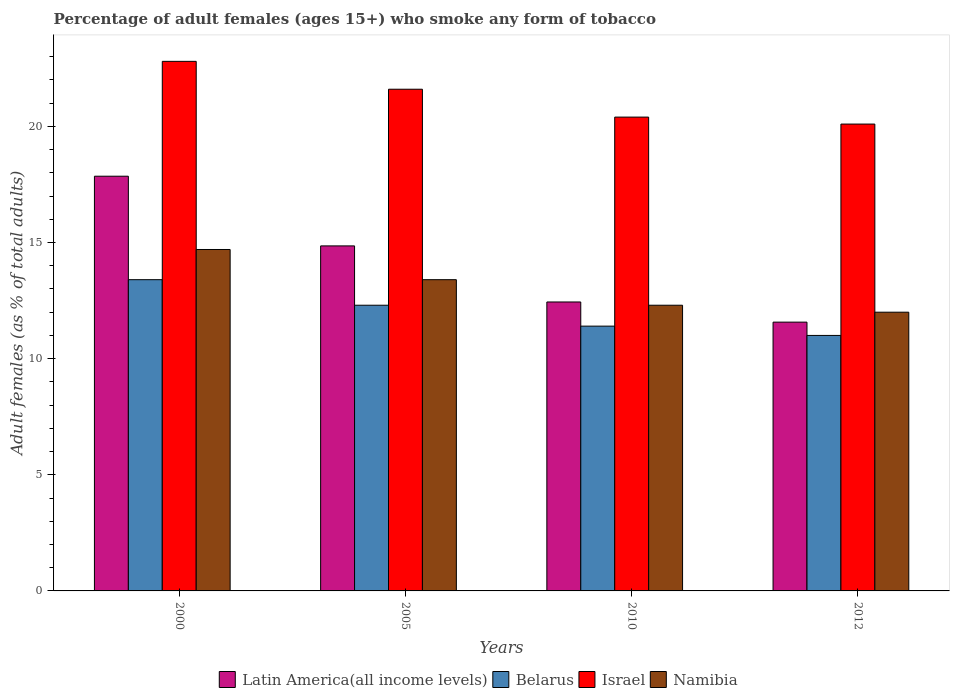How many groups of bars are there?
Keep it short and to the point. 4. Are the number of bars per tick equal to the number of legend labels?
Make the answer very short. Yes. Are the number of bars on each tick of the X-axis equal?
Your answer should be compact. Yes. How many bars are there on the 2nd tick from the left?
Your answer should be very brief. 4. What is the label of the 4th group of bars from the left?
Keep it short and to the point. 2012. In how many cases, is the number of bars for a given year not equal to the number of legend labels?
Your response must be concise. 0. What is the percentage of adult females who smoke in Belarus in 2012?
Your answer should be very brief. 11. Across all years, what is the maximum percentage of adult females who smoke in Latin America(all income levels)?
Keep it short and to the point. 17.85. Across all years, what is the minimum percentage of adult females who smoke in Latin America(all income levels)?
Ensure brevity in your answer.  11.57. In which year was the percentage of adult females who smoke in Namibia minimum?
Offer a terse response. 2012. What is the total percentage of adult females who smoke in Namibia in the graph?
Offer a very short reply. 52.4. What is the difference between the percentage of adult females who smoke in Namibia in 2000 and that in 2010?
Your response must be concise. 2.4. What is the difference between the percentage of adult females who smoke in Latin America(all income levels) in 2005 and the percentage of adult females who smoke in Namibia in 2012?
Your response must be concise. 2.85. What is the average percentage of adult females who smoke in Israel per year?
Give a very brief answer. 21.23. In the year 2010, what is the difference between the percentage of adult females who smoke in Israel and percentage of adult females who smoke in Namibia?
Make the answer very short. 8.1. In how many years, is the percentage of adult females who smoke in Belarus greater than 7 %?
Give a very brief answer. 4. What is the ratio of the percentage of adult females who smoke in Belarus in 2005 to that in 2010?
Provide a succinct answer. 1.08. Is the difference between the percentage of adult females who smoke in Israel in 2000 and 2005 greater than the difference between the percentage of adult females who smoke in Namibia in 2000 and 2005?
Ensure brevity in your answer.  No. What is the difference between the highest and the second highest percentage of adult females who smoke in Israel?
Your response must be concise. 1.2. What is the difference between the highest and the lowest percentage of adult females who smoke in Israel?
Keep it short and to the point. 2.7. In how many years, is the percentage of adult females who smoke in Namibia greater than the average percentage of adult females who smoke in Namibia taken over all years?
Provide a short and direct response. 2. Is the sum of the percentage of adult females who smoke in Belarus in 2005 and 2012 greater than the maximum percentage of adult females who smoke in Israel across all years?
Offer a terse response. Yes. Is it the case that in every year, the sum of the percentage of adult females who smoke in Latin America(all income levels) and percentage of adult females who smoke in Namibia is greater than the sum of percentage of adult females who smoke in Belarus and percentage of adult females who smoke in Israel?
Provide a short and direct response. No. What does the 3rd bar from the right in 2012 represents?
Offer a very short reply. Belarus. How many bars are there?
Offer a terse response. 16. Does the graph contain any zero values?
Your answer should be very brief. No. Where does the legend appear in the graph?
Ensure brevity in your answer.  Bottom center. How many legend labels are there?
Provide a succinct answer. 4. What is the title of the graph?
Offer a terse response. Percentage of adult females (ages 15+) who smoke any form of tobacco. Does "Albania" appear as one of the legend labels in the graph?
Offer a terse response. No. What is the label or title of the Y-axis?
Make the answer very short. Adult females (as % of total adults). What is the Adult females (as % of total adults) of Latin America(all income levels) in 2000?
Give a very brief answer. 17.85. What is the Adult females (as % of total adults) of Belarus in 2000?
Provide a short and direct response. 13.4. What is the Adult females (as % of total adults) in Israel in 2000?
Your response must be concise. 22.8. What is the Adult females (as % of total adults) in Namibia in 2000?
Make the answer very short. 14.7. What is the Adult females (as % of total adults) in Latin America(all income levels) in 2005?
Your answer should be very brief. 14.85. What is the Adult females (as % of total adults) in Belarus in 2005?
Give a very brief answer. 12.3. What is the Adult females (as % of total adults) in Israel in 2005?
Your answer should be very brief. 21.6. What is the Adult females (as % of total adults) of Latin America(all income levels) in 2010?
Make the answer very short. 12.44. What is the Adult females (as % of total adults) of Israel in 2010?
Your answer should be very brief. 20.4. What is the Adult females (as % of total adults) of Latin America(all income levels) in 2012?
Offer a very short reply. 11.57. What is the Adult females (as % of total adults) of Israel in 2012?
Your response must be concise. 20.1. Across all years, what is the maximum Adult females (as % of total adults) in Latin America(all income levels)?
Your answer should be compact. 17.85. Across all years, what is the maximum Adult females (as % of total adults) of Belarus?
Make the answer very short. 13.4. Across all years, what is the maximum Adult females (as % of total adults) of Israel?
Give a very brief answer. 22.8. Across all years, what is the maximum Adult females (as % of total adults) in Namibia?
Offer a terse response. 14.7. Across all years, what is the minimum Adult females (as % of total adults) of Latin America(all income levels)?
Keep it short and to the point. 11.57. Across all years, what is the minimum Adult females (as % of total adults) in Israel?
Keep it short and to the point. 20.1. Across all years, what is the minimum Adult females (as % of total adults) of Namibia?
Make the answer very short. 12. What is the total Adult females (as % of total adults) in Latin America(all income levels) in the graph?
Ensure brevity in your answer.  56.72. What is the total Adult females (as % of total adults) of Belarus in the graph?
Your answer should be very brief. 48.1. What is the total Adult females (as % of total adults) of Israel in the graph?
Your answer should be very brief. 84.9. What is the total Adult females (as % of total adults) in Namibia in the graph?
Provide a succinct answer. 52.4. What is the difference between the Adult females (as % of total adults) of Latin America(all income levels) in 2000 and that in 2005?
Provide a succinct answer. 3. What is the difference between the Adult females (as % of total adults) of Belarus in 2000 and that in 2005?
Ensure brevity in your answer.  1.1. What is the difference between the Adult females (as % of total adults) of Namibia in 2000 and that in 2005?
Provide a succinct answer. 1.3. What is the difference between the Adult females (as % of total adults) in Latin America(all income levels) in 2000 and that in 2010?
Give a very brief answer. 5.41. What is the difference between the Adult females (as % of total adults) of Belarus in 2000 and that in 2010?
Offer a terse response. 2. What is the difference between the Adult females (as % of total adults) of Israel in 2000 and that in 2010?
Give a very brief answer. 2.4. What is the difference between the Adult females (as % of total adults) of Namibia in 2000 and that in 2010?
Make the answer very short. 2.4. What is the difference between the Adult females (as % of total adults) in Latin America(all income levels) in 2000 and that in 2012?
Your answer should be very brief. 6.28. What is the difference between the Adult females (as % of total adults) of Israel in 2000 and that in 2012?
Offer a very short reply. 2.7. What is the difference between the Adult females (as % of total adults) of Latin America(all income levels) in 2005 and that in 2010?
Your response must be concise. 2.41. What is the difference between the Adult females (as % of total adults) of Belarus in 2005 and that in 2010?
Your answer should be very brief. 0.9. What is the difference between the Adult females (as % of total adults) of Namibia in 2005 and that in 2010?
Make the answer very short. 1.1. What is the difference between the Adult females (as % of total adults) of Latin America(all income levels) in 2005 and that in 2012?
Keep it short and to the point. 3.28. What is the difference between the Adult females (as % of total adults) of Belarus in 2005 and that in 2012?
Give a very brief answer. 1.3. What is the difference between the Adult females (as % of total adults) in Namibia in 2005 and that in 2012?
Your response must be concise. 1.4. What is the difference between the Adult females (as % of total adults) of Latin America(all income levels) in 2010 and that in 2012?
Your answer should be very brief. 0.87. What is the difference between the Adult females (as % of total adults) of Belarus in 2010 and that in 2012?
Make the answer very short. 0.4. What is the difference between the Adult females (as % of total adults) in Latin America(all income levels) in 2000 and the Adult females (as % of total adults) in Belarus in 2005?
Your answer should be compact. 5.55. What is the difference between the Adult females (as % of total adults) of Latin America(all income levels) in 2000 and the Adult females (as % of total adults) of Israel in 2005?
Provide a short and direct response. -3.75. What is the difference between the Adult females (as % of total adults) of Latin America(all income levels) in 2000 and the Adult females (as % of total adults) of Namibia in 2005?
Ensure brevity in your answer.  4.45. What is the difference between the Adult females (as % of total adults) of Belarus in 2000 and the Adult females (as % of total adults) of Israel in 2005?
Provide a succinct answer. -8.2. What is the difference between the Adult females (as % of total adults) in Israel in 2000 and the Adult females (as % of total adults) in Namibia in 2005?
Provide a short and direct response. 9.4. What is the difference between the Adult females (as % of total adults) of Latin America(all income levels) in 2000 and the Adult females (as % of total adults) of Belarus in 2010?
Your answer should be compact. 6.45. What is the difference between the Adult females (as % of total adults) of Latin America(all income levels) in 2000 and the Adult females (as % of total adults) of Israel in 2010?
Your response must be concise. -2.55. What is the difference between the Adult females (as % of total adults) in Latin America(all income levels) in 2000 and the Adult females (as % of total adults) in Namibia in 2010?
Your answer should be compact. 5.55. What is the difference between the Adult females (as % of total adults) of Belarus in 2000 and the Adult females (as % of total adults) of Israel in 2010?
Your answer should be very brief. -7. What is the difference between the Adult females (as % of total adults) of Israel in 2000 and the Adult females (as % of total adults) of Namibia in 2010?
Offer a terse response. 10.5. What is the difference between the Adult females (as % of total adults) in Latin America(all income levels) in 2000 and the Adult females (as % of total adults) in Belarus in 2012?
Your response must be concise. 6.85. What is the difference between the Adult females (as % of total adults) of Latin America(all income levels) in 2000 and the Adult females (as % of total adults) of Israel in 2012?
Your answer should be very brief. -2.25. What is the difference between the Adult females (as % of total adults) in Latin America(all income levels) in 2000 and the Adult females (as % of total adults) in Namibia in 2012?
Give a very brief answer. 5.85. What is the difference between the Adult females (as % of total adults) in Belarus in 2000 and the Adult females (as % of total adults) in Israel in 2012?
Ensure brevity in your answer.  -6.7. What is the difference between the Adult females (as % of total adults) in Latin America(all income levels) in 2005 and the Adult females (as % of total adults) in Belarus in 2010?
Your answer should be compact. 3.45. What is the difference between the Adult females (as % of total adults) of Latin America(all income levels) in 2005 and the Adult females (as % of total adults) of Israel in 2010?
Provide a succinct answer. -5.55. What is the difference between the Adult females (as % of total adults) in Latin America(all income levels) in 2005 and the Adult females (as % of total adults) in Namibia in 2010?
Provide a short and direct response. 2.55. What is the difference between the Adult females (as % of total adults) in Israel in 2005 and the Adult females (as % of total adults) in Namibia in 2010?
Your response must be concise. 9.3. What is the difference between the Adult females (as % of total adults) of Latin America(all income levels) in 2005 and the Adult females (as % of total adults) of Belarus in 2012?
Keep it short and to the point. 3.85. What is the difference between the Adult females (as % of total adults) of Latin America(all income levels) in 2005 and the Adult females (as % of total adults) of Israel in 2012?
Keep it short and to the point. -5.25. What is the difference between the Adult females (as % of total adults) of Latin America(all income levels) in 2005 and the Adult females (as % of total adults) of Namibia in 2012?
Offer a terse response. 2.85. What is the difference between the Adult females (as % of total adults) in Belarus in 2005 and the Adult females (as % of total adults) in Israel in 2012?
Provide a succinct answer. -7.8. What is the difference between the Adult females (as % of total adults) in Belarus in 2005 and the Adult females (as % of total adults) in Namibia in 2012?
Make the answer very short. 0.3. What is the difference between the Adult females (as % of total adults) in Latin America(all income levels) in 2010 and the Adult females (as % of total adults) in Belarus in 2012?
Your answer should be compact. 1.44. What is the difference between the Adult females (as % of total adults) of Latin America(all income levels) in 2010 and the Adult females (as % of total adults) of Israel in 2012?
Ensure brevity in your answer.  -7.66. What is the difference between the Adult females (as % of total adults) in Latin America(all income levels) in 2010 and the Adult females (as % of total adults) in Namibia in 2012?
Offer a very short reply. 0.44. What is the difference between the Adult females (as % of total adults) in Israel in 2010 and the Adult females (as % of total adults) in Namibia in 2012?
Your answer should be compact. 8.4. What is the average Adult females (as % of total adults) of Latin America(all income levels) per year?
Your response must be concise. 14.18. What is the average Adult females (as % of total adults) of Belarus per year?
Your answer should be compact. 12.03. What is the average Adult females (as % of total adults) of Israel per year?
Your response must be concise. 21.23. What is the average Adult females (as % of total adults) in Namibia per year?
Provide a succinct answer. 13.1. In the year 2000, what is the difference between the Adult females (as % of total adults) in Latin America(all income levels) and Adult females (as % of total adults) in Belarus?
Your answer should be very brief. 4.45. In the year 2000, what is the difference between the Adult females (as % of total adults) of Latin America(all income levels) and Adult females (as % of total adults) of Israel?
Give a very brief answer. -4.95. In the year 2000, what is the difference between the Adult females (as % of total adults) of Latin America(all income levels) and Adult females (as % of total adults) of Namibia?
Offer a terse response. 3.15. In the year 2000, what is the difference between the Adult females (as % of total adults) of Belarus and Adult females (as % of total adults) of Namibia?
Make the answer very short. -1.3. In the year 2000, what is the difference between the Adult females (as % of total adults) in Israel and Adult females (as % of total adults) in Namibia?
Ensure brevity in your answer.  8.1. In the year 2005, what is the difference between the Adult females (as % of total adults) of Latin America(all income levels) and Adult females (as % of total adults) of Belarus?
Provide a short and direct response. 2.55. In the year 2005, what is the difference between the Adult females (as % of total adults) of Latin America(all income levels) and Adult females (as % of total adults) of Israel?
Ensure brevity in your answer.  -6.75. In the year 2005, what is the difference between the Adult females (as % of total adults) of Latin America(all income levels) and Adult females (as % of total adults) of Namibia?
Ensure brevity in your answer.  1.45. In the year 2005, what is the difference between the Adult females (as % of total adults) of Belarus and Adult females (as % of total adults) of Israel?
Give a very brief answer. -9.3. In the year 2005, what is the difference between the Adult females (as % of total adults) in Belarus and Adult females (as % of total adults) in Namibia?
Give a very brief answer. -1.1. In the year 2010, what is the difference between the Adult females (as % of total adults) in Latin America(all income levels) and Adult females (as % of total adults) in Belarus?
Offer a terse response. 1.04. In the year 2010, what is the difference between the Adult females (as % of total adults) of Latin America(all income levels) and Adult females (as % of total adults) of Israel?
Offer a very short reply. -7.96. In the year 2010, what is the difference between the Adult females (as % of total adults) in Latin America(all income levels) and Adult females (as % of total adults) in Namibia?
Ensure brevity in your answer.  0.14. In the year 2010, what is the difference between the Adult females (as % of total adults) in Belarus and Adult females (as % of total adults) in Israel?
Offer a very short reply. -9. In the year 2012, what is the difference between the Adult females (as % of total adults) of Latin America(all income levels) and Adult females (as % of total adults) of Belarus?
Your response must be concise. 0.57. In the year 2012, what is the difference between the Adult females (as % of total adults) in Latin America(all income levels) and Adult females (as % of total adults) in Israel?
Offer a very short reply. -8.53. In the year 2012, what is the difference between the Adult females (as % of total adults) of Latin America(all income levels) and Adult females (as % of total adults) of Namibia?
Keep it short and to the point. -0.43. In the year 2012, what is the difference between the Adult females (as % of total adults) of Belarus and Adult females (as % of total adults) of Namibia?
Provide a succinct answer. -1. In the year 2012, what is the difference between the Adult females (as % of total adults) of Israel and Adult females (as % of total adults) of Namibia?
Provide a succinct answer. 8.1. What is the ratio of the Adult females (as % of total adults) in Latin America(all income levels) in 2000 to that in 2005?
Offer a terse response. 1.2. What is the ratio of the Adult females (as % of total adults) in Belarus in 2000 to that in 2005?
Ensure brevity in your answer.  1.09. What is the ratio of the Adult females (as % of total adults) in Israel in 2000 to that in 2005?
Offer a terse response. 1.06. What is the ratio of the Adult females (as % of total adults) of Namibia in 2000 to that in 2005?
Keep it short and to the point. 1.1. What is the ratio of the Adult females (as % of total adults) in Latin America(all income levels) in 2000 to that in 2010?
Offer a very short reply. 1.44. What is the ratio of the Adult females (as % of total adults) of Belarus in 2000 to that in 2010?
Provide a succinct answer. 1.18. What is the ratio of the Adult females (as % of total adults) of Israel in 2000 to that in 2010?
Your answer should be very brief. 1.12. What is the ratio of the Adult females (as % of total adults) of Namibia in 2000 to that in 2010?
Give a very brief answer. 1.2. What is the ratio of the Adult females (as % of total adults) of Latin America(all income levels) in 2000 to that in 2012?
Make the answer very short. 1.54. What is the ratio of the Adult females (as % of total adults) of Belarus in 2000 to that in 2012?
Your answer should be compact. 1.22. What is the ratio of the Adult females (as % of total adults) of Israel in 2000 to that in 2012?
Provide a succinct answer. 1.13. What is the ratio of the Adult females (as % of total adults) in Namibia in 2000 to that in 2012?
Give a very brief answer. 1.23. What is the ratio of the Adult females (as % of total adults) of Latin America(all income levels) in 2005 to that in 2010?
Keep it short and to the point. 1.19. What is the ratio of the Adult females (as % of total adults) of Belarus in 2005 to that in 2010?
Your answer should be compact. 1.08. What is the ratio of the Adult females (as % of total adults) of Israel in 2005 to that in 2010?
Your response must be concise. 1.06. What is the ratio of the Adult females (as % of total adults) in Namibia in 2005 to that in 2010?
Your answer should be compact. 1.09. What is the ratio of the Adult females (as % of total adults) of Latin America(all income levels) in 2005 to that in 2012?
Your answer should be very brief. 1.28. What is the ratio of the Adult females (as % of total adults) in Belarus in 2005 to that in 2012?
Your answer should be compact. 1.12. What is the ratio of the Adult females (as % of total adults) of Israel in 2005 to that in 2012?
Make the answer very short. 1.07. What is the ratio of the Adult females (as % of total adults) of Namibia in 2005 to that in 2012?
Your answer should be compact. 1.12. What is the ratio of the Adult females (as % of total adults) of Latin America(all income levels) in 2010 to that in 2012?
Keep it short and to the point. 1.07. What is the ratio of the Adult females (as % of total adults) in Belarus in 2010 to that in 2012?
Offer a very short reply. 1.04. What is the ratio of the Adult females (as % of total adults) of Israel in 2010 to that in 2012?
Your response must be concise. 1.01. What is the ratio of the Adult females (as % of total adults) of Namibia in 2010 to that in 2012?
Provide a succinct answer. 1.02. What is the difference between the highest and the second highest Adult females (as % of total adults) in Latin America(all income levels)?
Keep it short and to the point. 3. What is the difference between the highest and the second highest Adult females (as % of total adults) of Namibia?
Ensure brevity in your answer.  1.3. What is the difference between the highest and the lowest Adult females (as % of total adults) in Latin America(all income levels)?
Keep it short and to the point. 6.28. What is the difference between the highest and the lowest Adult females (as % of total adults) of Namibia?
Make the answer very short. 2.7. 